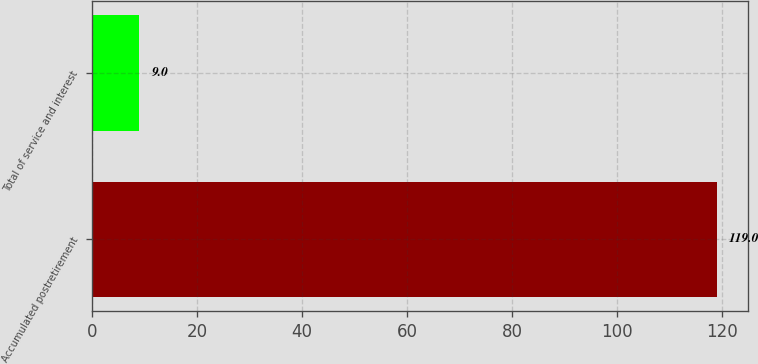<chart> <loc_0><loc_0><loc_500><loc_500><bar_chart><fcel>Accumulated postretirement<fcel>Total of service and interest<nl><fcel>119<fcel>9<nl></chart> 